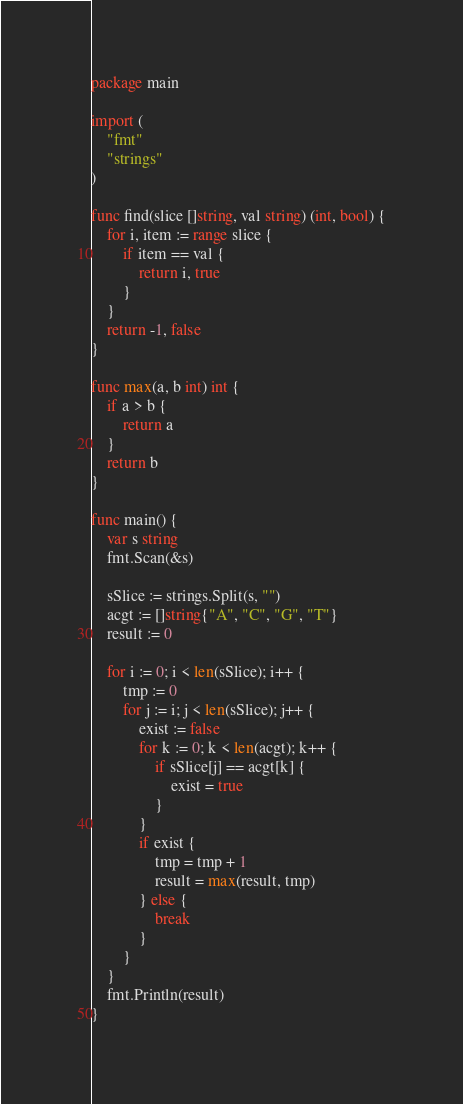<code> <loc_0><loc_0><loc_500><loc_500><_Go_>package main

import (
	"fmt"
	"strings"
)

func find(slice []string, val string) (int, bool) {
	for i, item := range slice {
		if item == val {
			return i, true
		}
	}
	return -1, false
}

func max(a, b int) int {
	if a > b {
		return a
	}
	return b
}

func main() {
	var s string
	fmt.Scan(&s)

	sSlice := strings.Split(s, "")
	acgt := []string{"A", "C", "G", "T"}
	result := 0

	for i := 0; i < len(sSlice); i++ {
		tmp := 0
		for j := i; j < len(sSlice); j++ {
			exist := false
			for k := 0; k < len(acgt); k++ {
				if sSlice[j] == acgt[k] {
					exist = true
				}
			}
			if exist {
				tmp = tmp + 1
				result = max(result, tmp)
			} else {
				break
			}
		}
	}
	fmt.Println(result)
}
</code> 